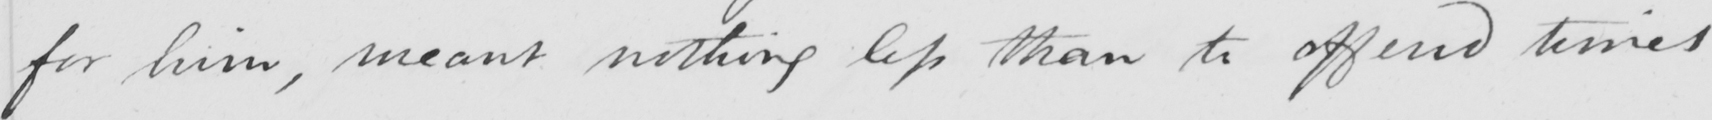What does this handwritten line say? for him , meant nothing less than to offend times 